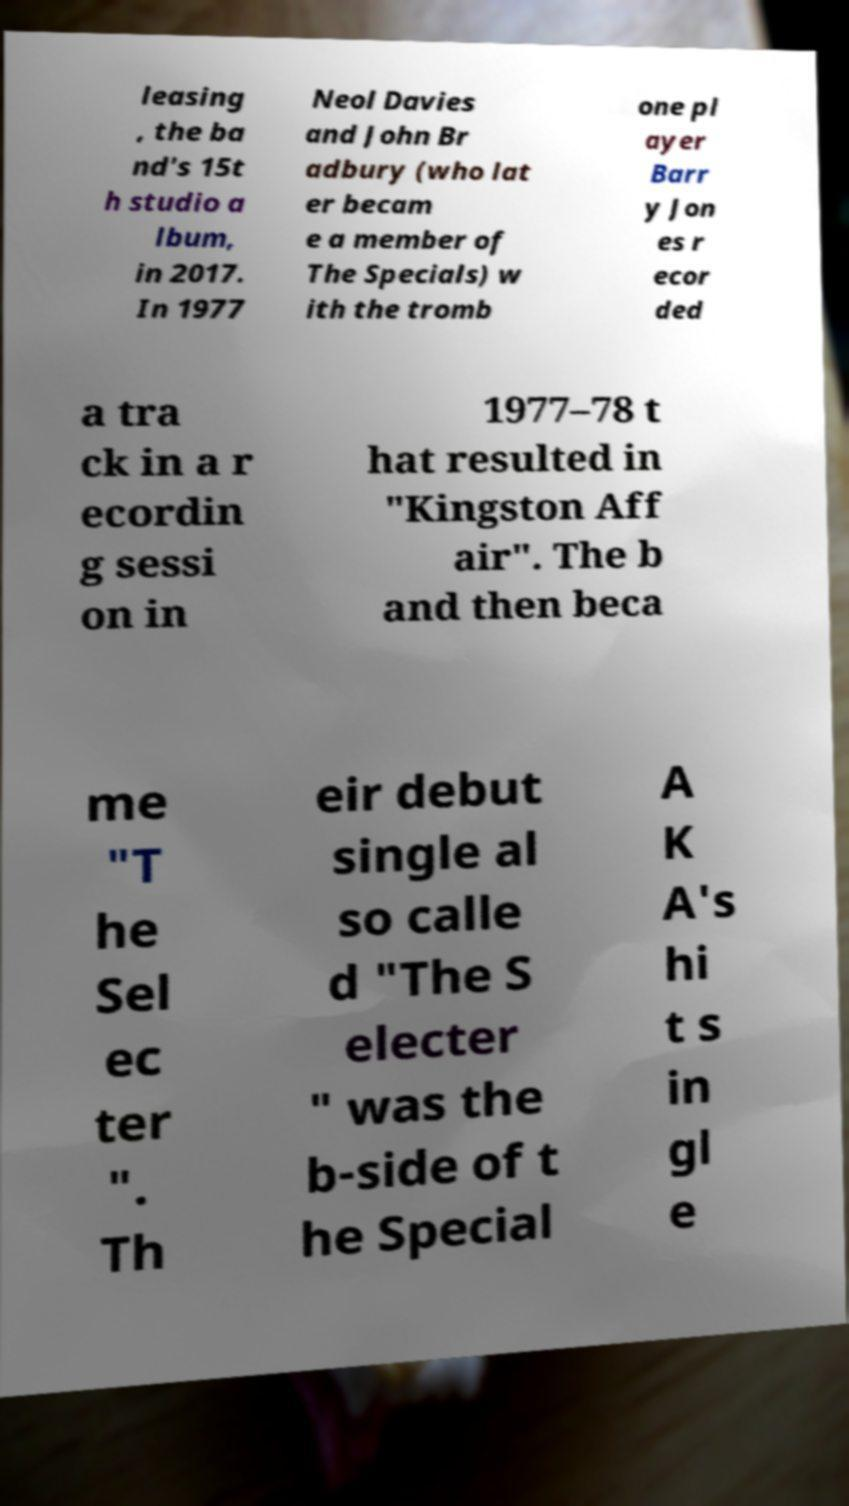Can you read and provide the text displayed in the image?This photo seems to have some interesting text. Can you extract and type it out for me? leasing , the ba nd's 15t h studio a lbum, in 2017. In 1977 Neol Davies and John Br adbury (who lat er becam e a member of The Specials) w ith the tromb one pl ayer Barr y Jon es r ecor ded a tra ck in a r ecordin g sessi on in 1977–78 t hat resulted in "Kingston Aff air". The b and then beca me "T he Sel ec ter ". Th eir debut single al so calle d "The S electer " was the b-side of t he Special A K A's hi t s in gl e 